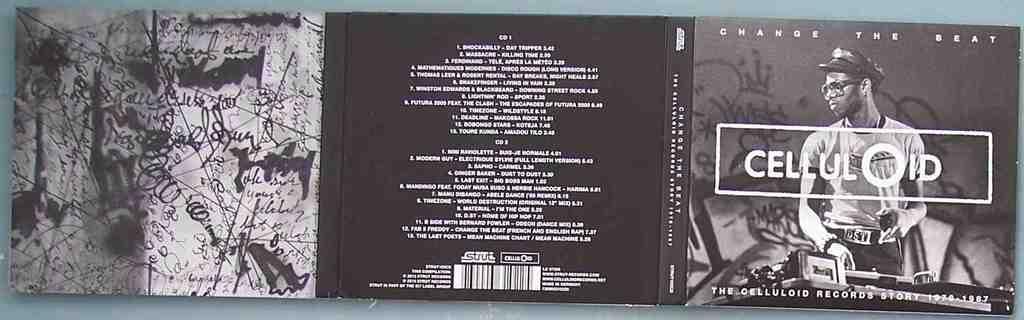What's the title of the album?
Provide a short and direct response. Celluloid. 